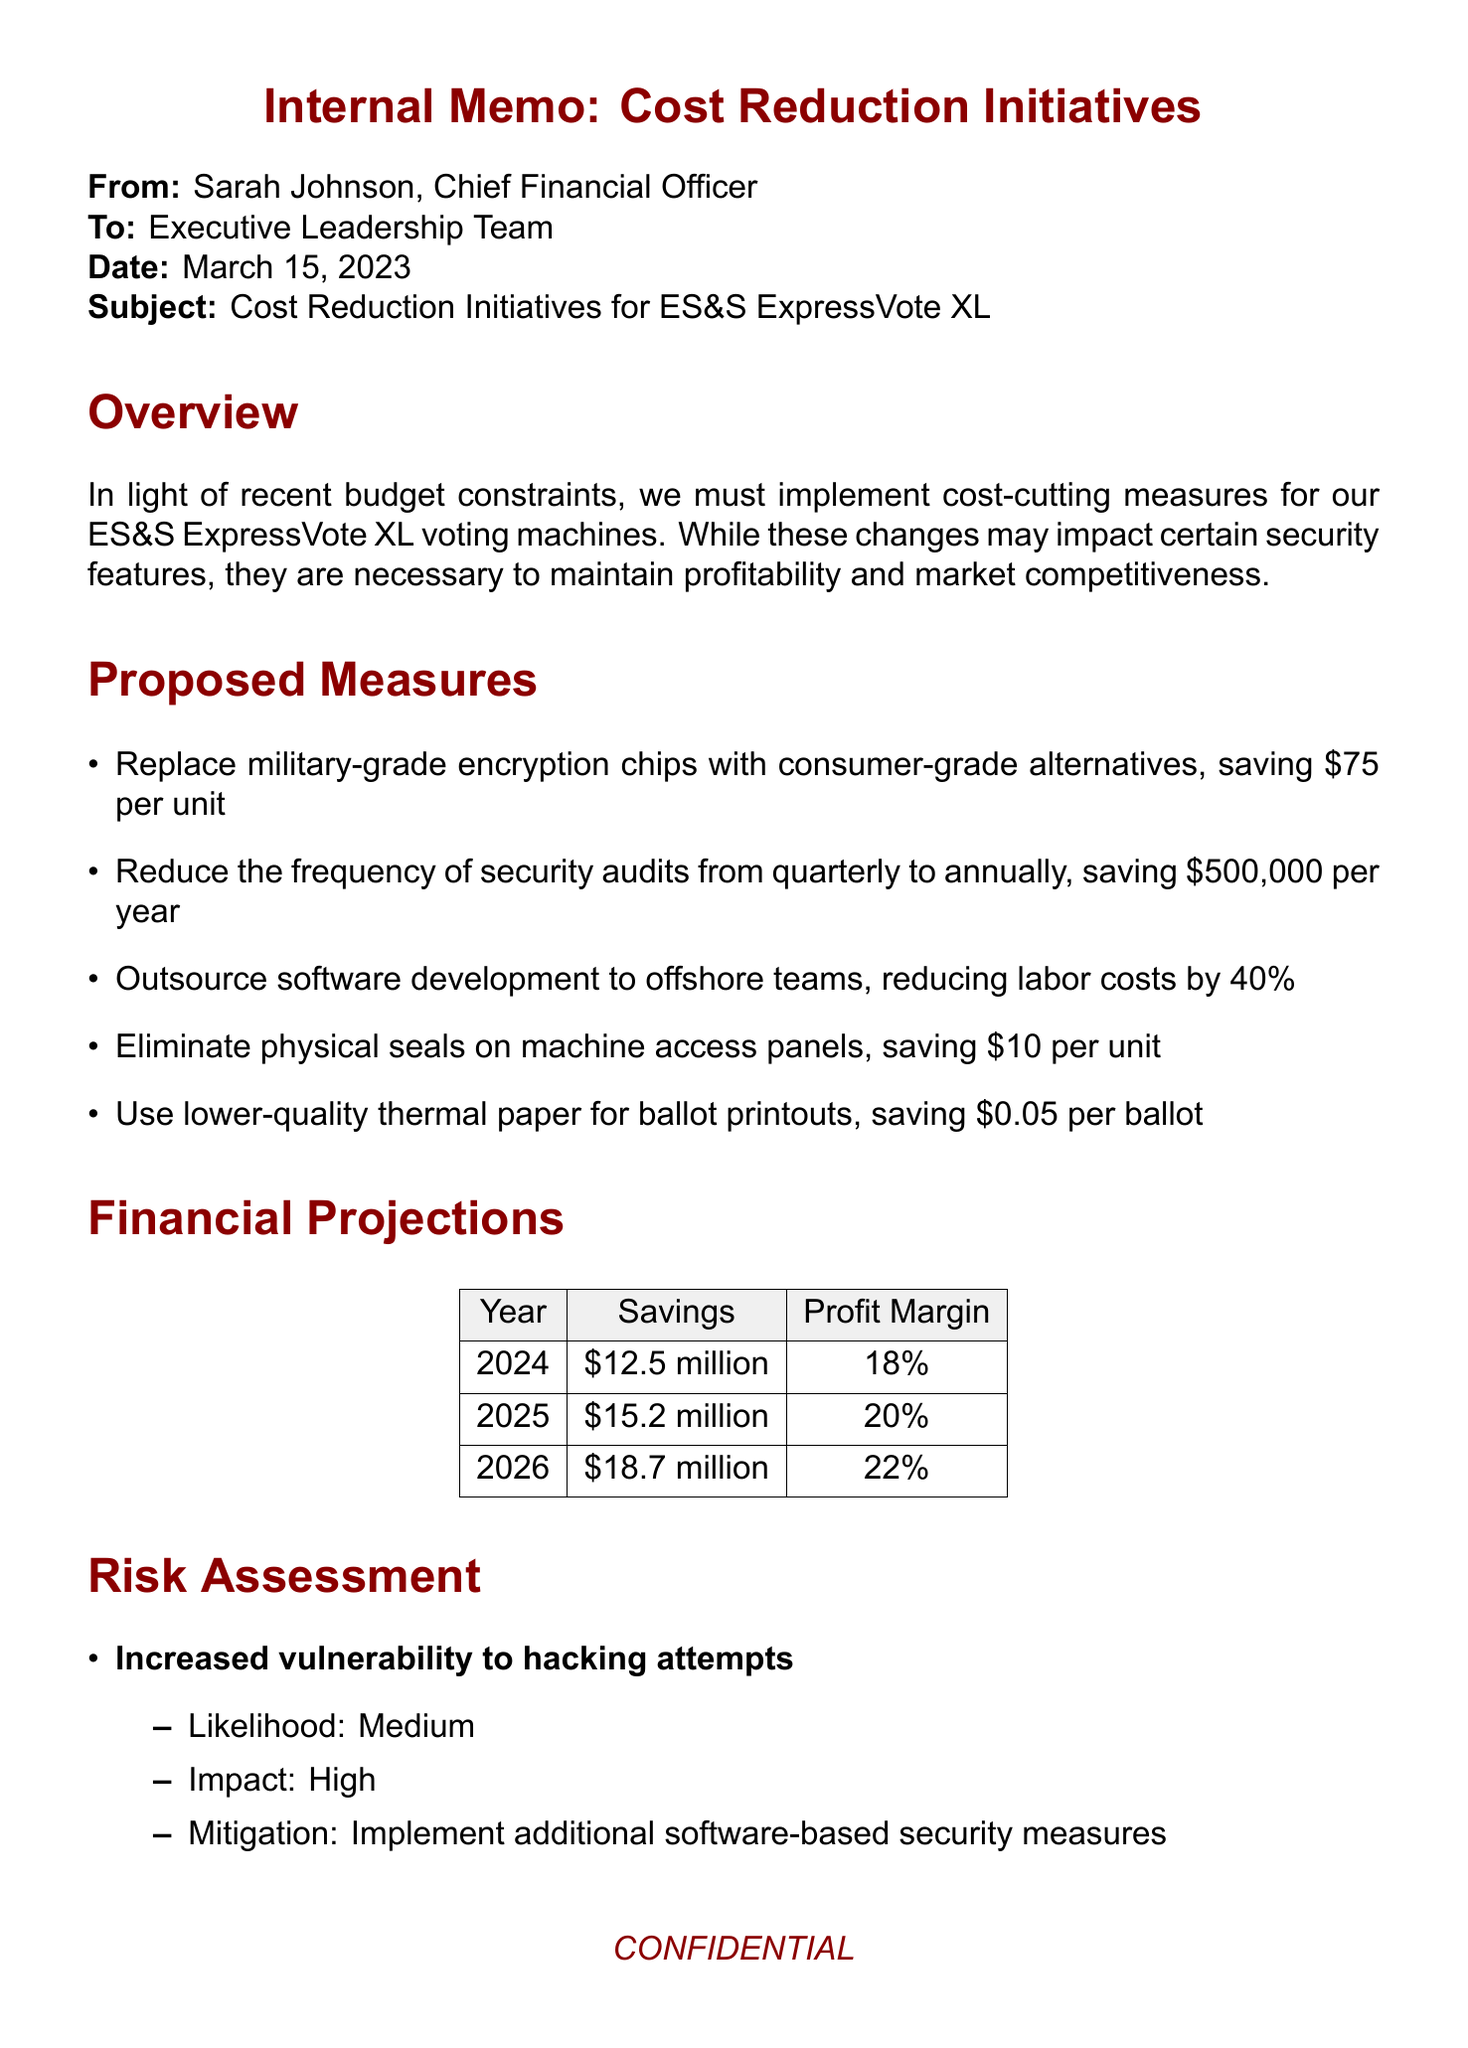What is the subject of the internal memo? The subject is stated at the beginning of the memo and it details the actions being taken regarding the ES&S ExpressVote XL.
Answer: Cost Reduction Initiatives for ES&S ExpressVote XL Who is the sender of the internal memo? The sender is identified in the "From" section of the memo.
Answer: Sarah Johnson, Chief Financial Officer How much will be saved by outsourcing software development? The memo lists the cost-saving measures, specifying the percentage reduction in labor costs achieved by outsourcing.
Answer: 40% What is the projected savings in 2025? The financial projections specifically outline the expected savings for each year.
Answer: $15.2 million What is the likelihood of increased vulnerability to hacking attempts? The risk assessment section provides an evaluation of the likelihood of this specific risk.
Answer: Medium Which mitigation strategy is suggested for negative public perception? The risk assessment discusses potential risks and their proposed mitigations, including marketing strategies.
Answer: Enhance marketing efforts to emphasize overall system reliability What is the cost of the current high-quality thermal paper? The ballot paper cost analysis section identifies specific costs related to ballot printing.
Answer: $0.15/ballot How much is saved per unit by eliminating physical seals on machine access panels? The proposed measures section details individual savings from various cost-cutting actions.
Answer: $10 per unit What is the impact assessment for the potential loss of certification? The risk assessment evaluates the impact of this risk in relation to its likelihood.
Answer: High 